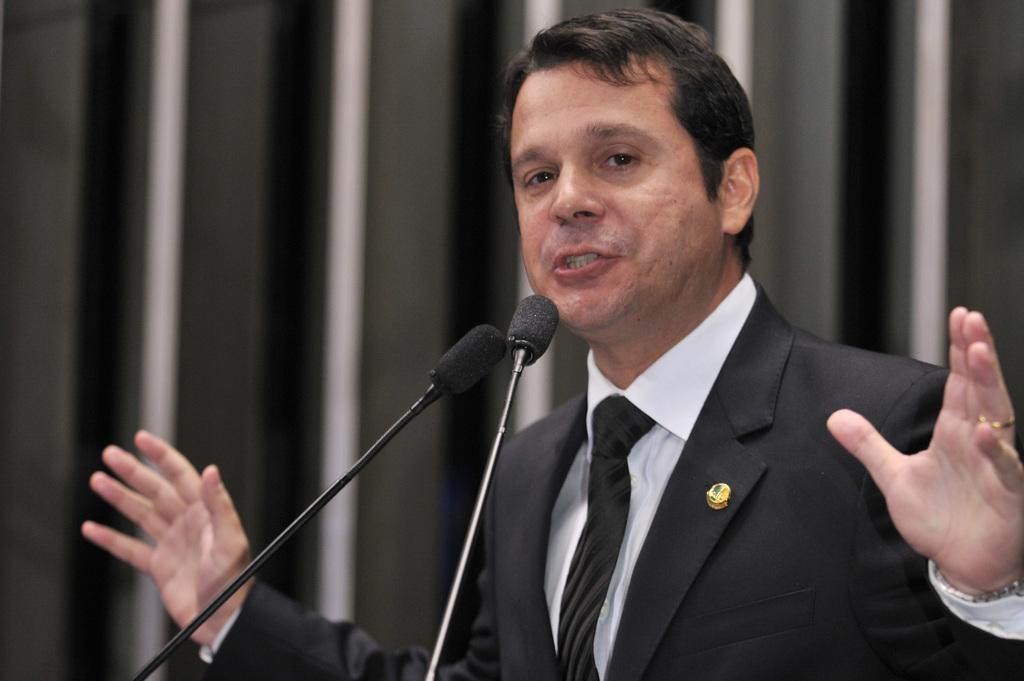Who is the main subject in the image? There is a man in the image. What is the man doing in the image? The mics in front of the man suggest that he might be speaking or performing. Can you describe the background of the image? The background of the image appears blurry. What type of hat is the man wearing in the image? There is no hat visible on the man in the image. What is the source of noise in the image? The image does not depict any noise or sound; it is a still image. 